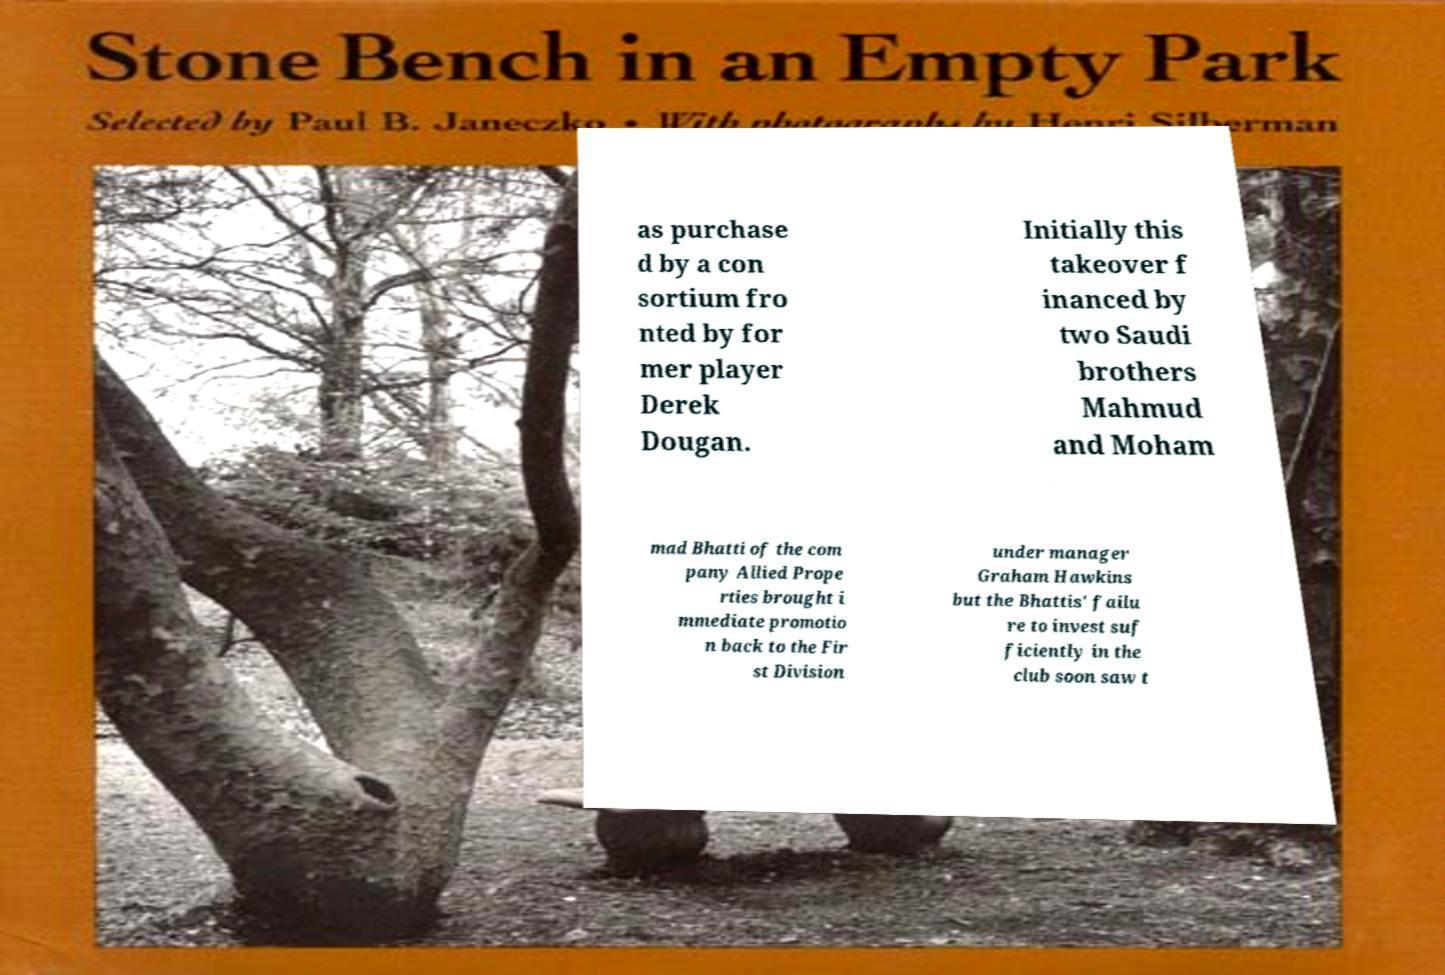Could you extract and type out the text from this image? as purchase d by a con sortium fro nted by for mer player Derek Dougan. Initially this takeover f inanced by two Saudi brothers Mahmud and Moham mad Bhatti of the com pany Allied Prope rties brought i mmediate promotio n back to the Fir st Division under manager Graham Hawkins but the Bhattis' failu re to invest suf ficiently in the club soon saw t 